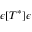Convert formula to latex. <formula><loc_0><loc_0><loc_500><loc_500>\epsilon [ T ^ { * } ] \epsilon</formula> 